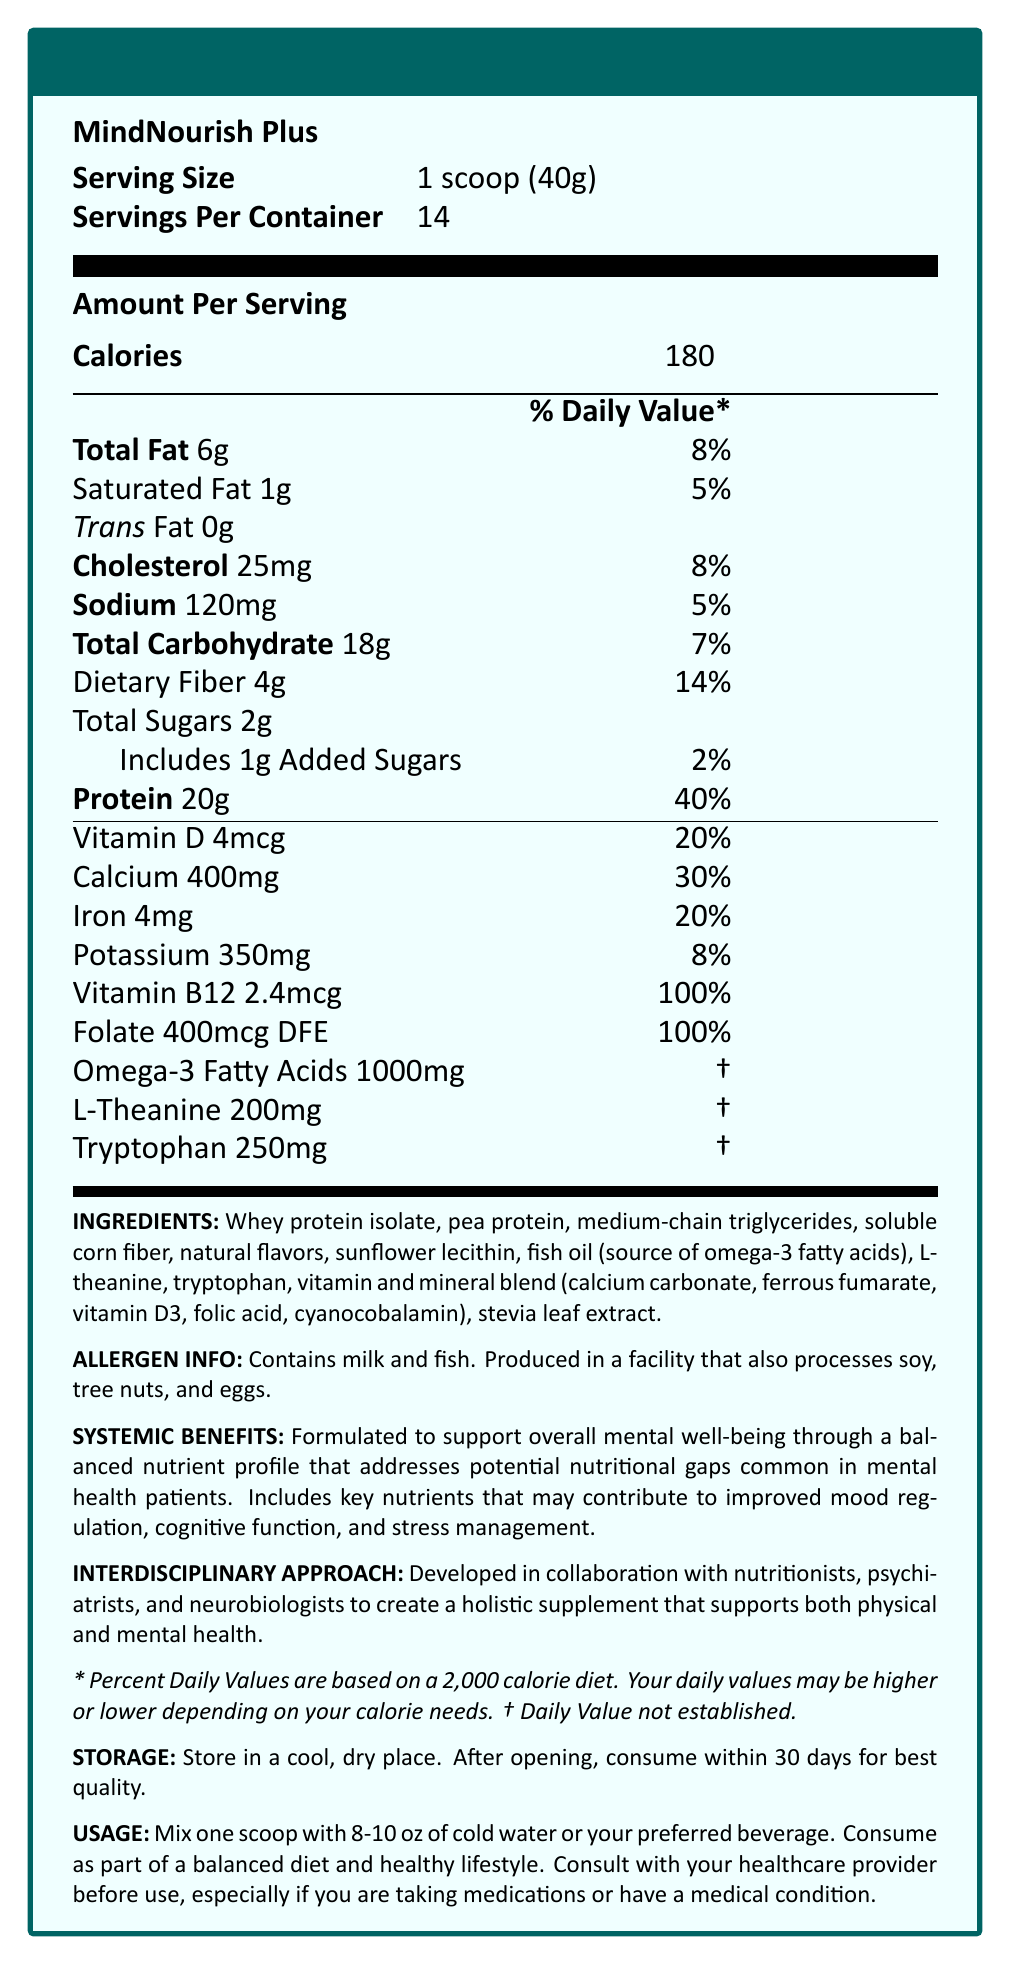what is the serving size of MindNourish Plus? The serving size is clearly listed under the "Serving Size" section of the Nutrition Facts.
Answer: 1 scoop (40g) how many servings are there in one container of MindNourish Plus? The number of servings per container is specified as 14 under "Servings Per Container".
Answer: 14 what is the amount of protein per serving, and what percent of the daily value does it represent? The "Protein" section indicates 20g of protein per serving, which is 40% of the daily value.
Answer: 20g, 40% how much dietary fiber is present in each serving? The "Dietary Fiber" section indicates that each serving contains 4g of dietary fiber.
Answer: 4g what is the main goal of the MindNourish Plus supplement? The "Systemic Benefits" section mentions that the product is formulated to support overall mental well-being.
Answer: Support overall mental well-being which nutrient contributes the highest percentage of the daily value per serving?  A. Vitamin D B. Calcium C. Iron D. Folate The daily value for Folate per serving is 100%, which is the highest among the listed nutrients.
Answer: D. Folate what allergens are contained in MindNourish Plus? 1. Soy 2. Tree nuts 3. Milk 4. Fish The "Allergen Info" section states that the product contains milk and fish, but it is produced in a facility that also processes soy and tree nuts.
Answer: 3 and 4 is there any added sugar in MindNourish Plus? The label states that it includes 1g of added sugars, which is 2% of the daily value.
Answer: Yes does MindNourish Plus contain omega-3 fatty acids? The label specifies that each serving contains 1000mg of omega-3 fatty acids.
Answer: Yes describe the main features and benefits of MindNourish Plus. This summary covers the product name, purpose, key nutrients and their benefits, and the interdisciplinary approach used in its development, as detailed in the document.
Answer: MindNourish Plus is a meal replacement shake formulated to support overall mental well-being. It provides a balanced nutrient profile that addresses potential nutritional gaps common in mental health patients. It contains key nutrients such as proteins, omega-3 fatty acids, L-theanine, and tryptophan, which may contribute to better mood regulation, cognitive function, and stress management. The product is developed in collaboration with nutritionists, psychiatrists, and neurobiologists to create a holistic supplement supporting both physical and mental health. what is the recommended storage condition for MindNourish Plus after opening? The "Storage" section provides clear instructions to store the product in a cool, dry place and consume it within 30 days after opening.
Answer: Store in a cool, dry place; consume within 30 days how many calories are in one serving of MindNourish Plus? The "Calories" section indicates that one serving contains 180 calories.
Answer: 180 calories what specialists were involved in developing MindNourish Plus? A. Nutritionists B. Cardiologists C. Psychiatrists D. Neurobiologists E. Dermatologists The "Interdisciplinary Approach" section states that the product was developed with input from nutritionists, psychiatrists, and neurobiologists.
Answer: A, C, and D can you determine if MindNourish Plus is gluten-free? The document does not provide any information regarding the presence or absence of gluten in the product.
Answer: Not enough information does the product recommend consulting a healthcare provider before use? The "Usage" section recommends consulting with a healthcare provider before use, especially if taking medications or having a medical condition.
Answer: Yes how does the document highlight the mental health benefits of MindNourish Plus? The "Systemic Benefits" and "Interdisciplinary Approach" sections emphasize the mental health benefits and the holistic approach to its development.
Answer: It states that the product is formulated to support overall mental well-being, improve mood regulation, cognitive function, and stress management. 